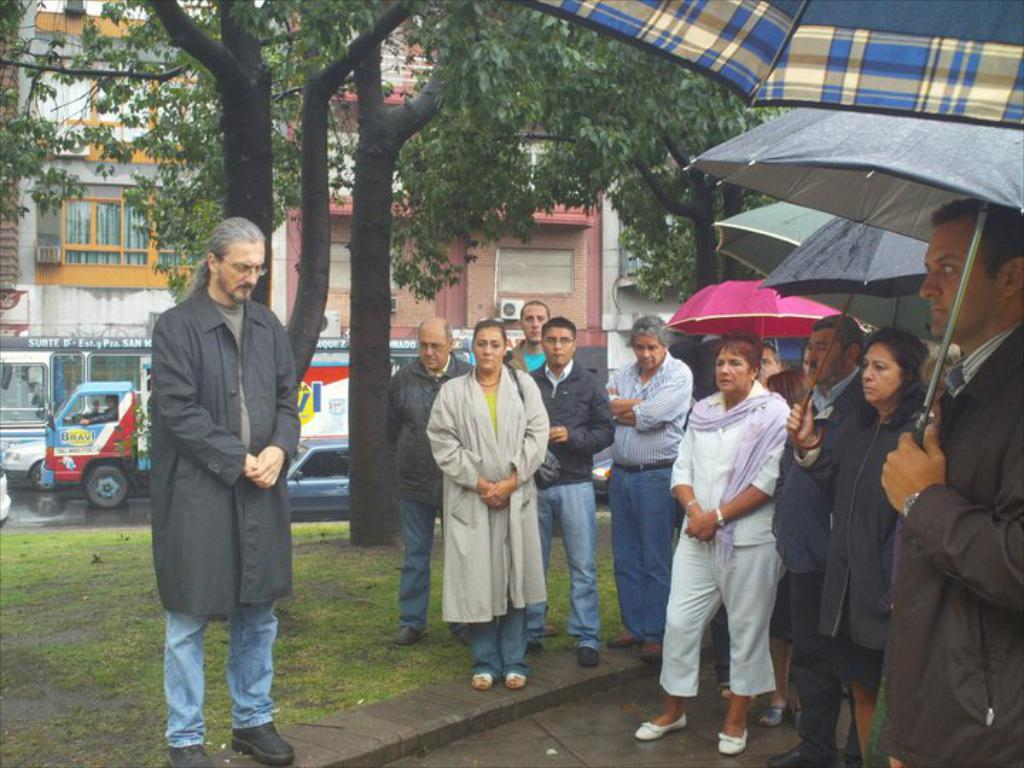How many people are in the group visible in the image? There is a group of people in the image, but the exact number cannot be determined from the provided facts. What are some people in the group doing? Some people in the group are holding umbrellas. What can be seen in the background of the image? There are trees, vehicles on the road, and buildings in the background. What type of egg is being used as a hat by the goat in the image? There is no goat or egg present in the image. What type of loaf is being carried by the person in the image? There is no loaf visible in the image. 